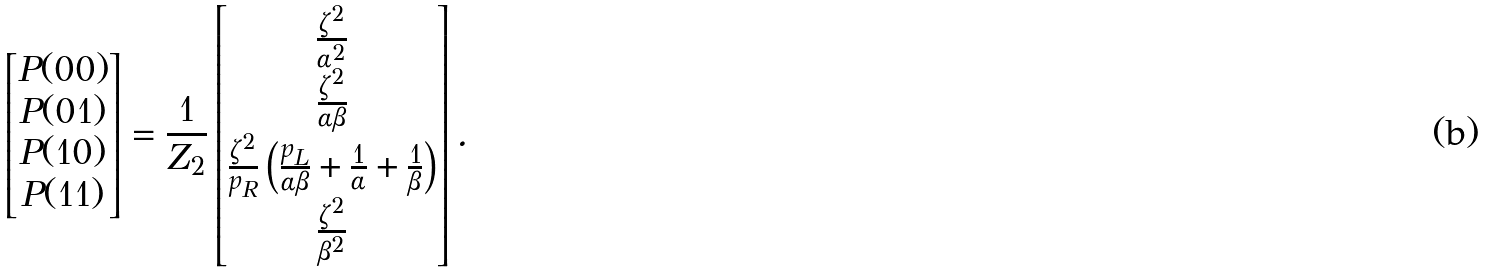Convert formula to latex. <formula><loc_0><loc_0><loc_500><loc_500>\begin{bmatrix} P ( 0 0 ) \\ P ( 0 1 ) \\ P ( 1 0 ) \\ P ( 1 1 ) \end{bmatrix} = \frac { 1 } { Z _ { 2 } } \begin{bmatrix} \frac { \zeta ^ { 2 } } { \alpha ^ { 2 } } \\ \frac { \zeta ^ { 2 } } { \alpha \beta } \\ \frac { \zeta ^ { 2 } } { p _ { R } } \left ( \frac { p _ { L } } { \alpha \beta } + \frac { 1 } { \alpha } + \frac { 1 } { \beta } \right ) \\ \frac { \zeta ^ { 2 } } { \beta ^ { 2 } } \end{bmatrix} .</formula> 